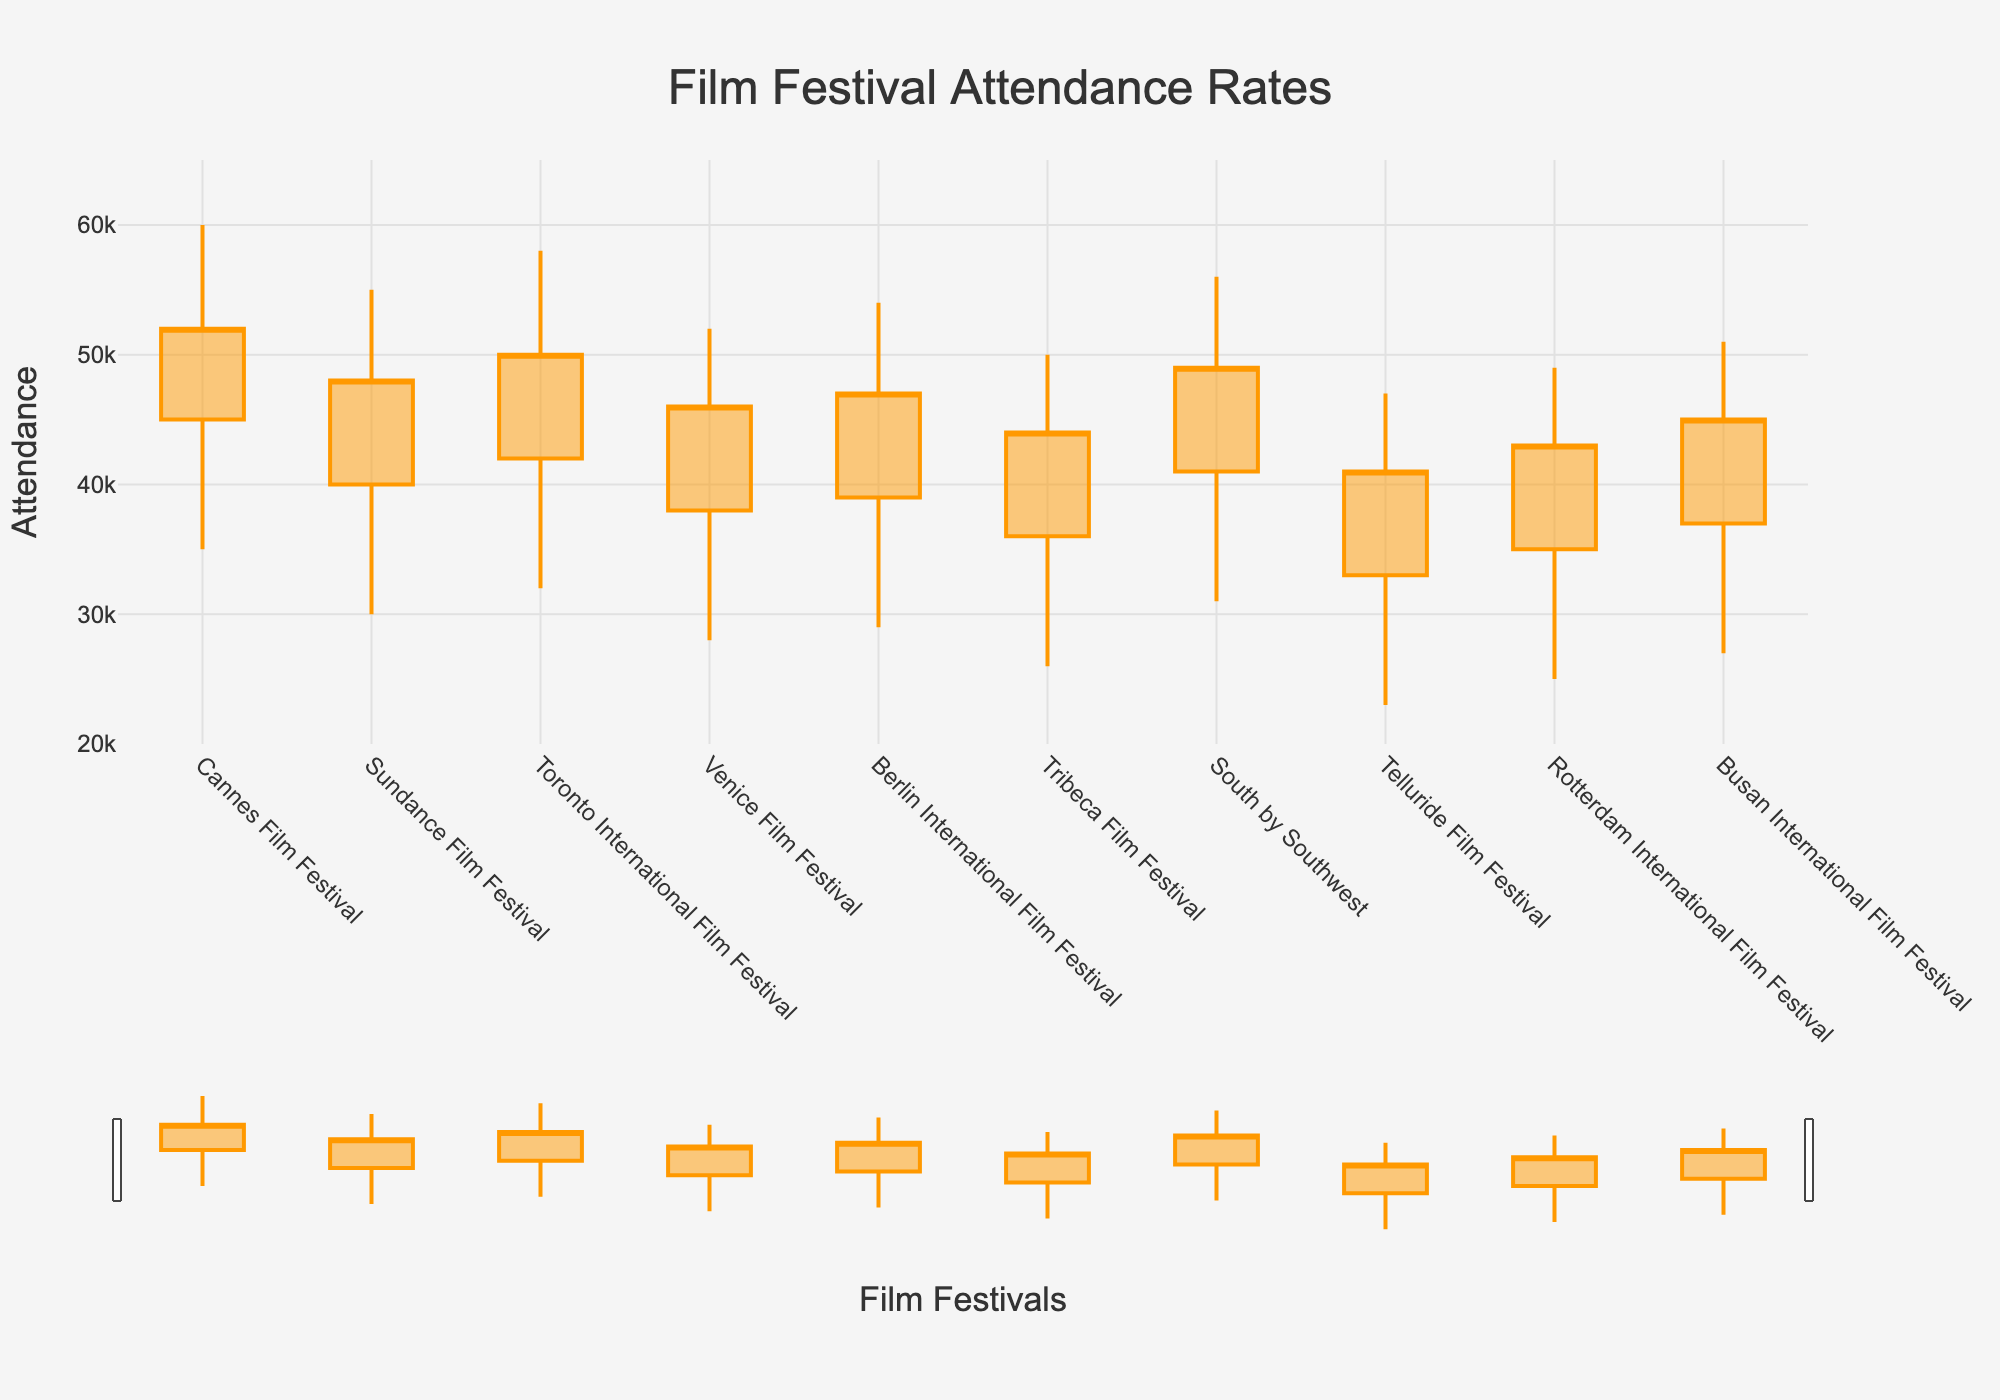What is the title of the chart? The title is placed prominently at the top of the chart and reads "Film Festival Attendance Rates".
Answer: Film Festival Attendance Rates Which film festival had the highest peak attendance? By looking at the highest values (peak) within each OHLC bar, Cannes Film Festival shows the highest peak attendance at 60,000.
Answer: Cannes Film Festival What is the closing attendance for the Sundance Film Festival? The closing attendance is represented by the horizontal line on the right side of the candlestick; for Sundance Film Festival, it is 48,000.
Answer: 48,000 How many festivals have a peak attendance of at least 55,000? By observing the highest point of each OHLC bar, there are four festivals with a peak attendance of at least 55,000: Cannes Film Festival (60,000), Sundance Film Festival (55,000), Toronto International Film Festival (58,000), and South by Southwest (56,000).
Answer: 4 Which festival has the largest range between its lowest and peak attendance? The range can be calculated by subtracting the lowest attendance from the peak attendance. Cannes Film Festival has the largest range (60,000 - 35,000 = 25,000).
Answer: Cannes Film Festival Which film festival has a closing attendance higher than its peak attendance? By comparing each festival's closing and peak attendance values, none of the festivals have a closing attendance higher than their peak attendance.
Answer: None What is the average opening attendance for all the festivals? Add all opening attendance numbers: (45000 + 40000 + 42000 + 38000 + 39000 + 36000 + 41000 + 33000 + 35000 + 37000) = 386,000. Divide by the number of festivals (10) to find the average: 386,000 / 10 = 38,600
Answer: 38,600 Which film festival has the smallest gap between its opening and closing attendance? The gap can be calculated by subtracting the opening attendance from the closing attendance. Tribeca Film Festival has the smallest gap (44,000 - 36,000 = 8,000).
Answer: Tribeca Film Festival How does the attendance pattern of Busan International Film Festival compare to Berlin International Film Festival in terms of highest and lowest attendance? Busan International Film Festival has a peak attendance of 51,000 and a lowest attendance of 27,000. Berlin International Film Festival has a peak attendance of 54,000 and a lowest attendance of 29,000.
Answer: Berlin International Film Festival has higher peak and lowest attendance than Busan International Film Festival 